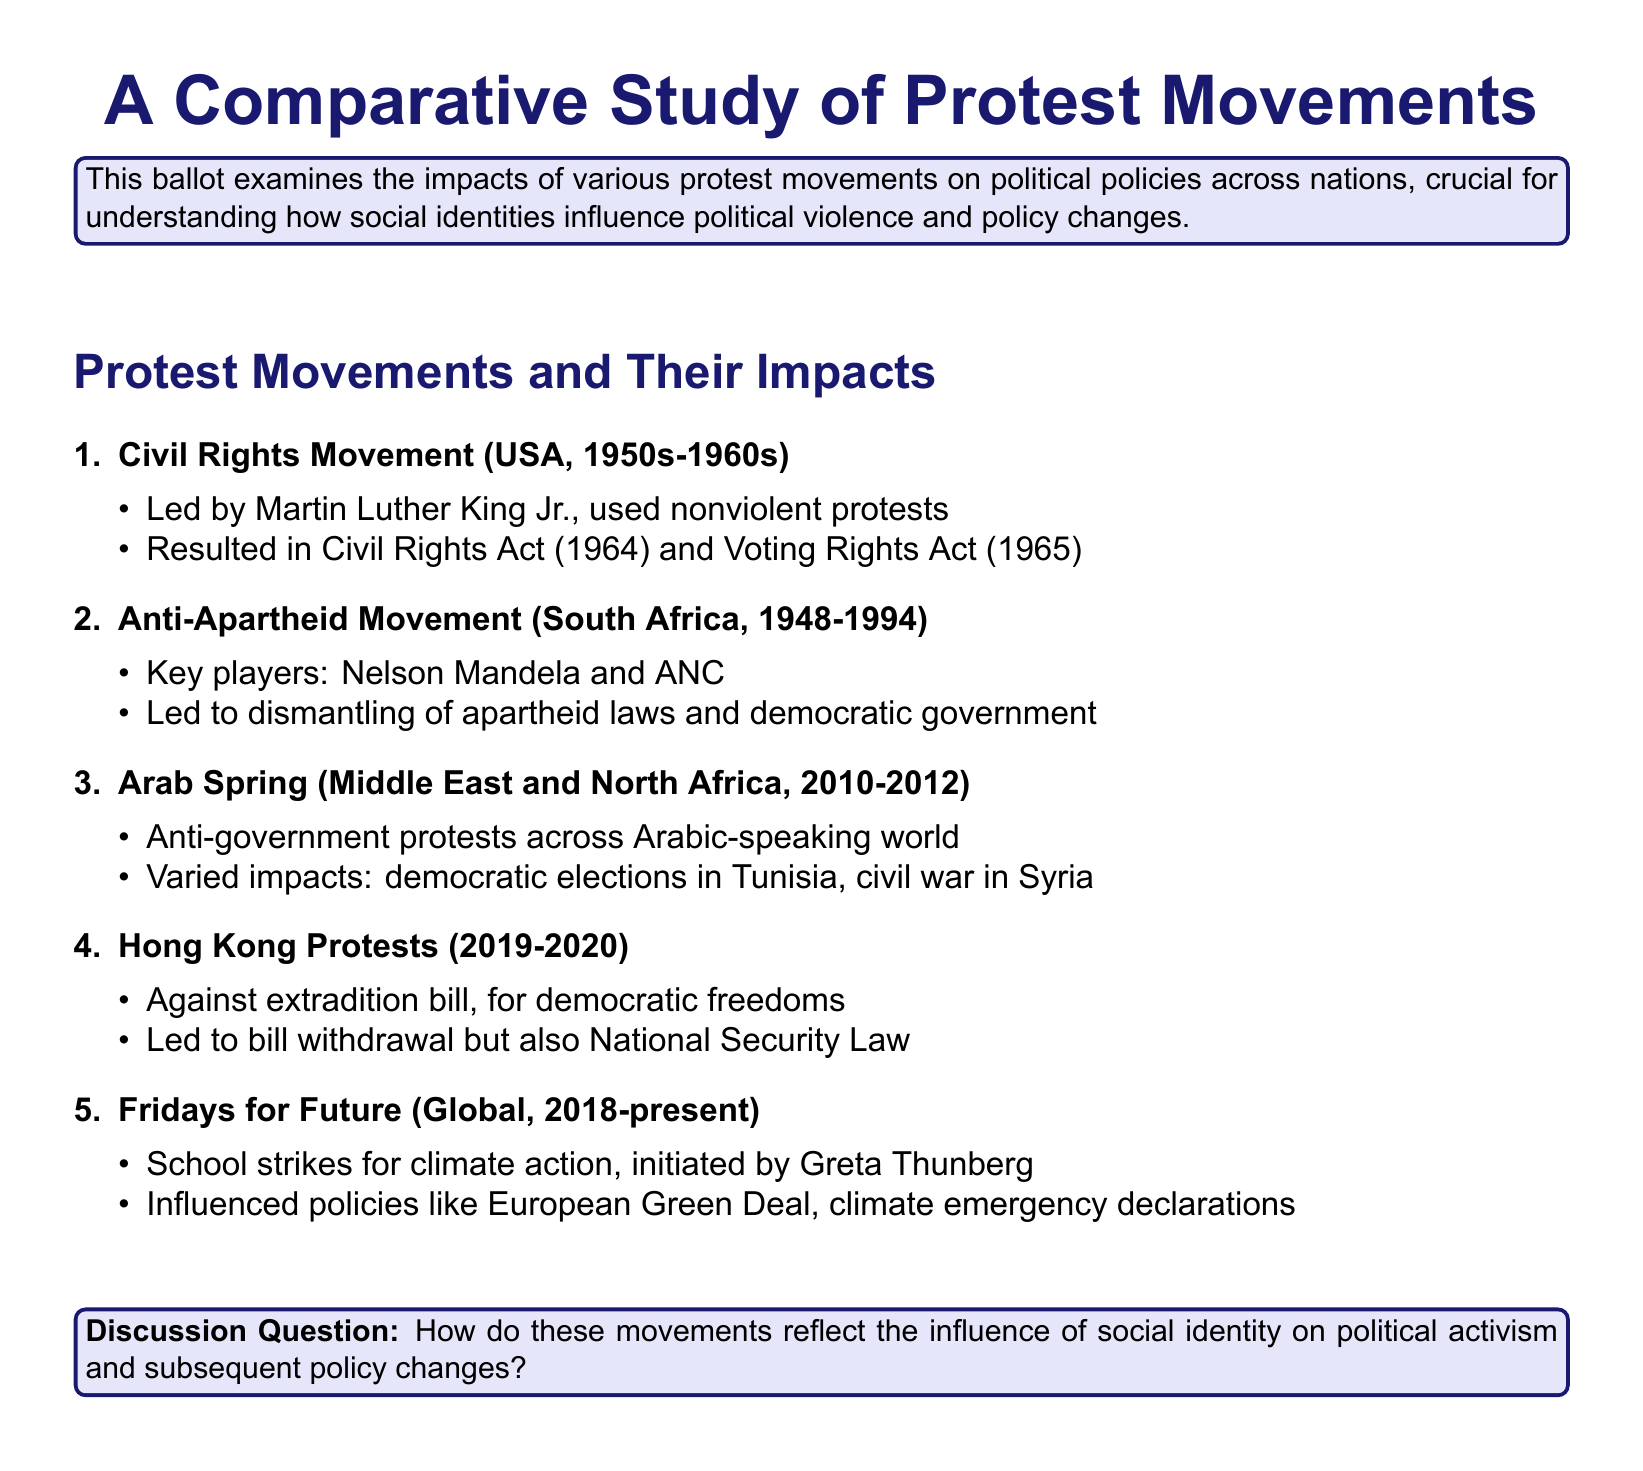What is the main focus of the study? The main focus of the study is to examine the impacts of various protest movements on political policies across nations.
Answer: impacts of various protest movements on political policies Who led the Civil Rights Movement? The leader of the Civil Rights Movement was Martin Luther King Jr.
Answer: Martin Luther King Jr What significant acts resulted from the Civil Rights Movement? The significant acts that resulted were the Civil Rights Act and the Voting Rights Act.
Answer: Civil Rights Act, Voting Rights Act Which movement is associated with Nelson Mandela? The movement associated with Nelson Mandela is the Anti-Apartheid Movement.
Answer: Anti-Apartheid Movement What year did the Arab Spring take place? The Arab Spring took place between 2010 and 2012.
Answer: 2010-2012 What was the main reason for the Hong Kong protests? The main reason for the Hong Kong protests was against the extradition bill.
Answer: against the extradition bill Which global protest movement was initiated by Greta Thunberg? The global protest movement initiated by Greta Thunberg is Fridays for Future.
Answer: Fridays for Future What policy was influenced by the Fridays for Future movement? The Fridays for Future movement influenced the European Green Deal.
Answer: European Green Deal Why did the Hong Kong protests lead to new legislation? The Hong Kong protests led to new legislation due to the government’s response to the protests.
Answer: National Security Law 